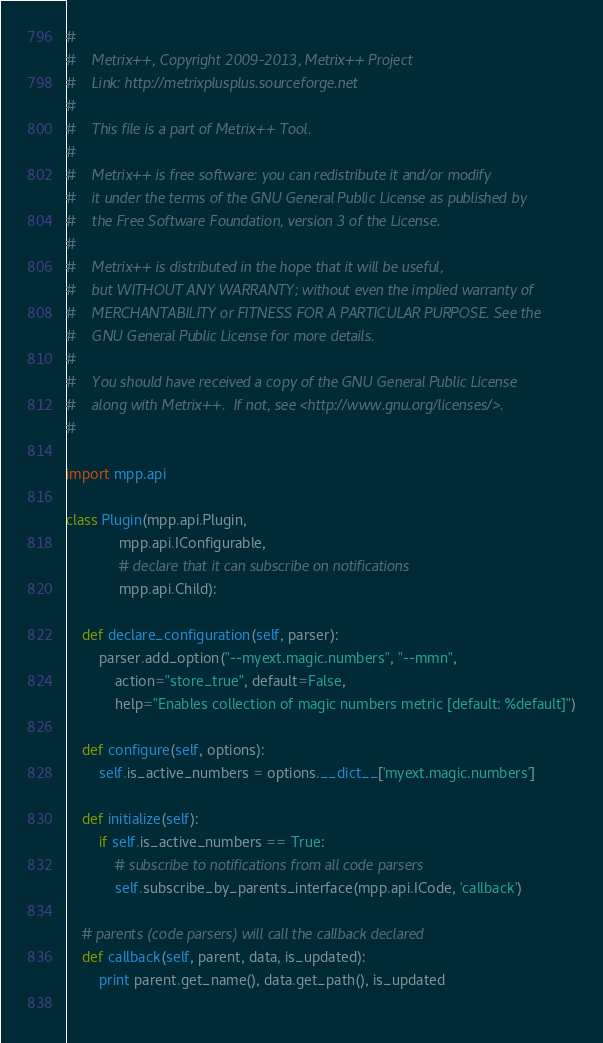Convert code to text. <code><loc_0><loc_0><loc_500><loc_500><_Python_>#
#    Metrix++, Copyright 2009-2013, Metrix++ Project
#    Link: http://metrixplusplus.sourceforge.net
#    
#    This file is a part of Metrix++ Tool.
#    
#    Metrix++ is free software: you can redistribute it and/or modify
#    it under the terms of the GNU General Public License as published by
#    the Free Software Foundation, version 3 of the License.
#    
#    Metrix++ is distributed in the hope that it will be useful,
#    but WITHOUT ANY WARRANTY; without even the implied warranty of
#    MERCHANTABILITY or FITNESS FOR A PARTICULAR PURPOSE. See the
#    GNU General Public License for more details.
#    
#    You should have received a copy of the GNU General Public License
#    along with Metrix++.  If not, see <http://www.gnu.org/licenses/>.
#

import mpp.api

class Plugin(mpp.api.Plugin,
             mpp.api.IConfigurable,
             # declare that it can subscribe on notifications
             mpp.api.Child):
    
    def declare_configuration(self, parser):
        parser.add_option("--myext.magic.numbers", "--mmn",
            action="store_true", default=False,
            help="Enables collection of magic numbers metric [default: %default]")
    
    def configure(self, options):
        self.is_active_numbers = options.__dict__['myext.magic.numbers']
    
    def initialize(self):
        if self.is_active_numbers == True:
            # subscribe to notifications from all code parsers
            self.subscribe_by_parents_interface(mpp.api.ICode, 'callback')

    # parents (code parsers) will call the callback declared
    def callback(self, parent, data, is_updated):
        print parent.get_name(), data.get_path(), is_updated
        </code> 